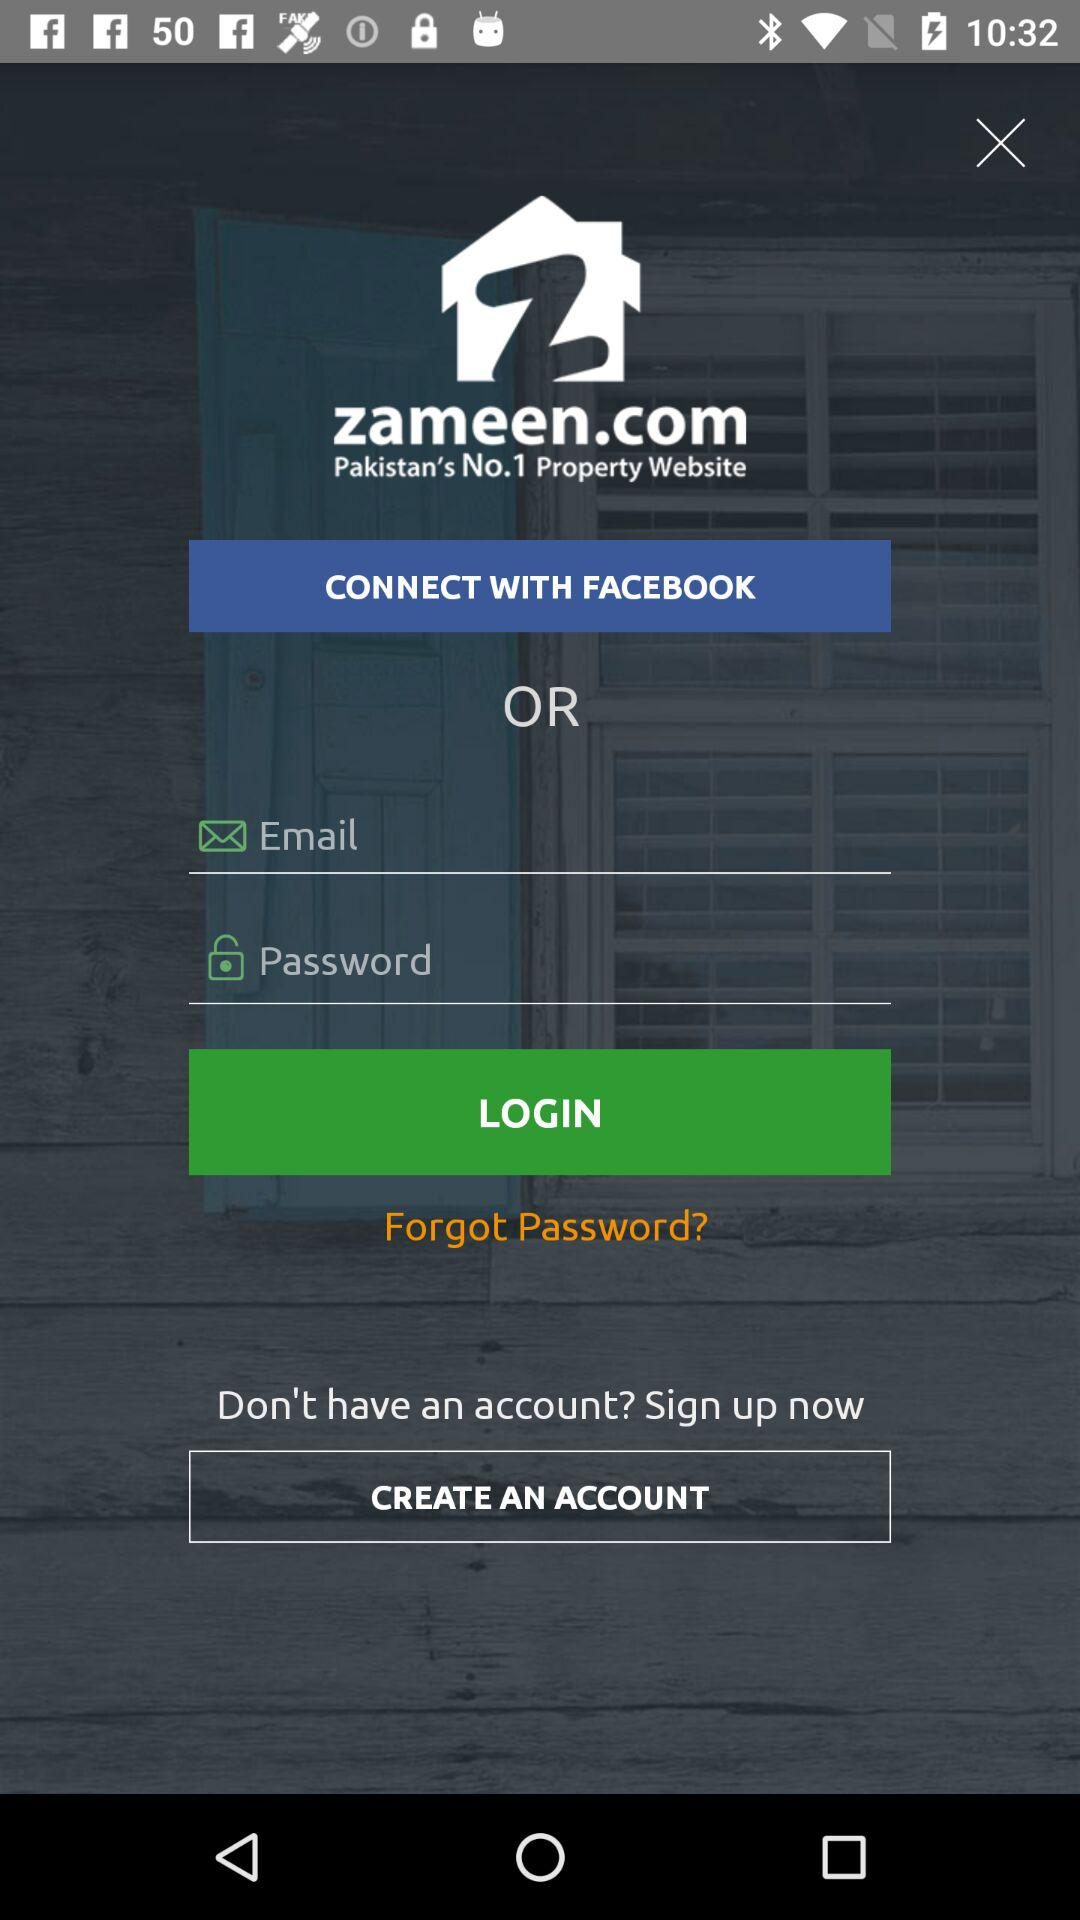Which language is selected? The selected language is English. 